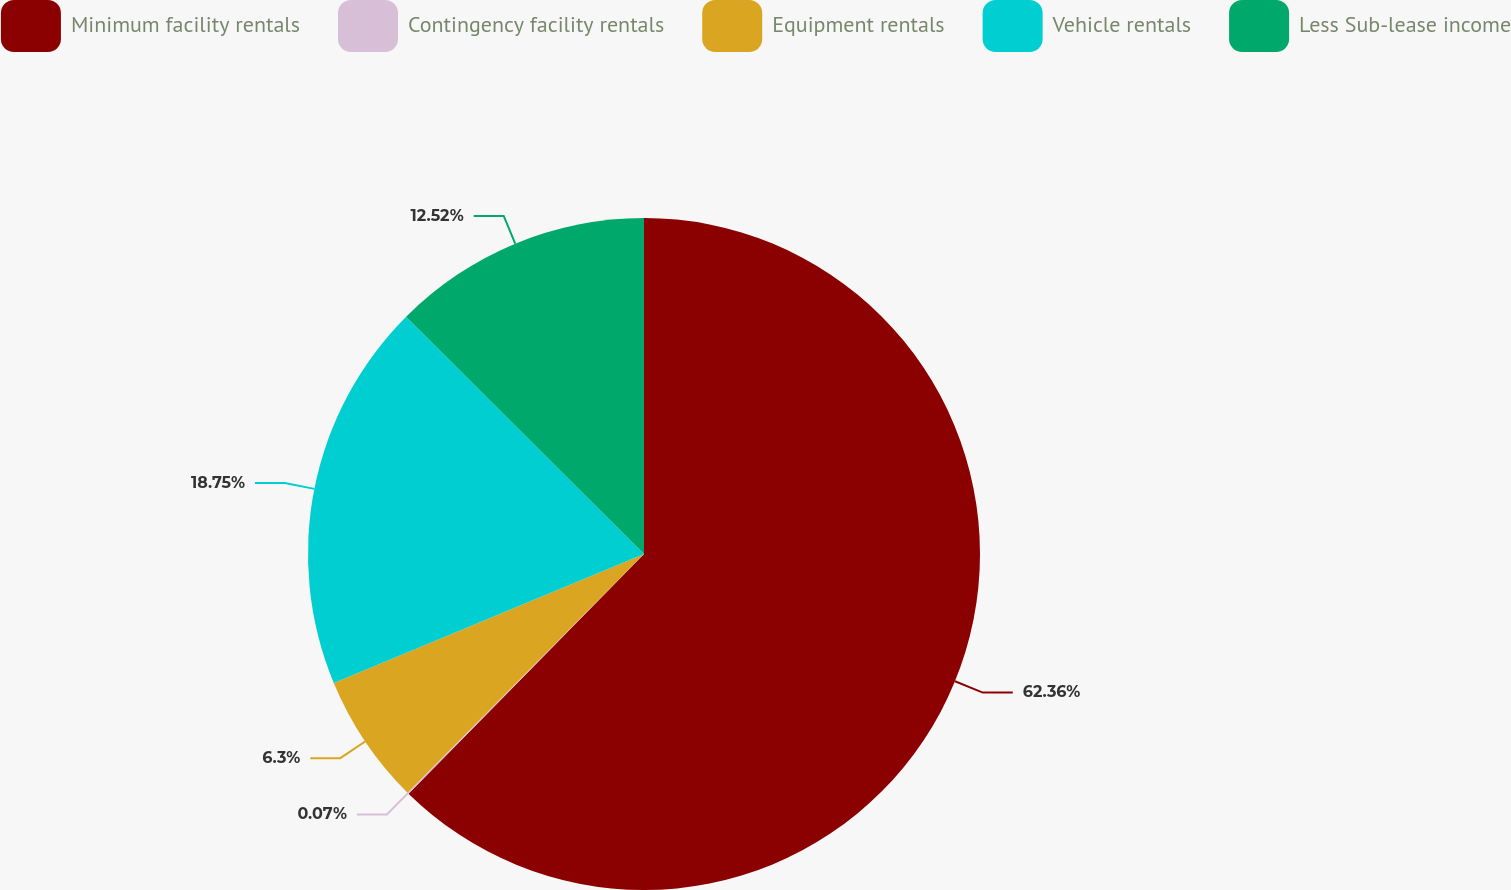Convert chart to OTSL. <chart><loc_0><loc_0><loc_500><loc_500><pie_chart><fcel>Minimum facility rentals<fcel>Contingency facility rentals<fcel>Equipment rentals<fcel>Vehicle rentals<fcel>Less Sub-lease income<nl><fcel>62.36%<fcel>0.07%<fcel>6.3%<fcel>18.75%<fcel>12.52%<nl></chart> 